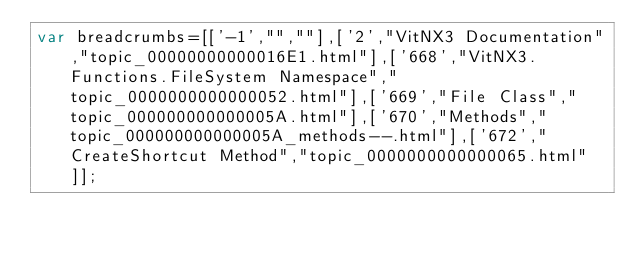<code> <loc_0><loc_0><loc_500><loc_500><_JavaScript_>var breadcrumbs=[['-1',"",""],['2',"VitNX3 Documentation","topic_00000000000016E1.html"],['668',"VitNX3.Functions.FileSystem Namespace","topic_0000000000000052.html"],['669',"File Class","topic_000000000000005A.html"],['670',"Methods","topic_000000000000005A_methods--.html"],['672',"CreateShortcut Method","topic_0000000000000065.html"]];</code> 